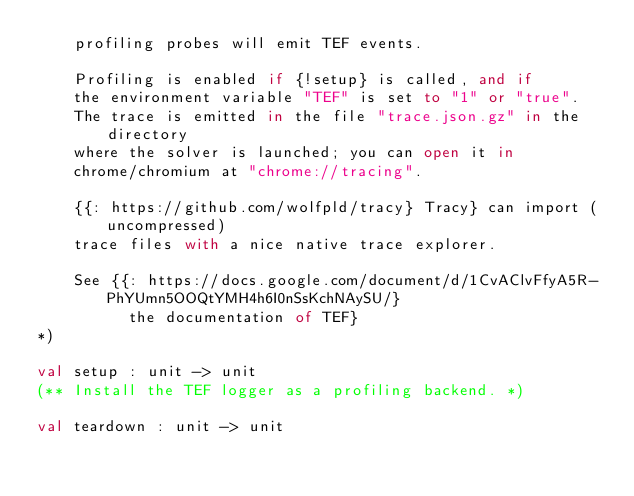Convert code to text. <code><loc_0><loc_0><loc_500><loc_500><_OCaml_>    profiling probes will emit TEF events.

    Profiling is enabled if {!setup} is called, and if
    the environment variable "TEF" is set to "1" or "true".
    The trace is emitted in the file "trace.json.gz" in the directory
    where the solver is launched; you can open it in
    chrome/chromium at "chrome://tracing".

    {{: https://github.com/wolfpld/tracy} Tracy} can import (uncompressed)
    trace files with a nice native trace explorer.

    See {{: https://docs.google.com/document/d/1CvAClvFfyA5R-PhYUmn5OOQtYMH4h6I0nSsKchNAySU/}
          the documentation of TEF}
*)

val setup : unit -> unit
(** Install the TEF logger as a profiling backend. *)

val teardown : unit -> unit
</code> 